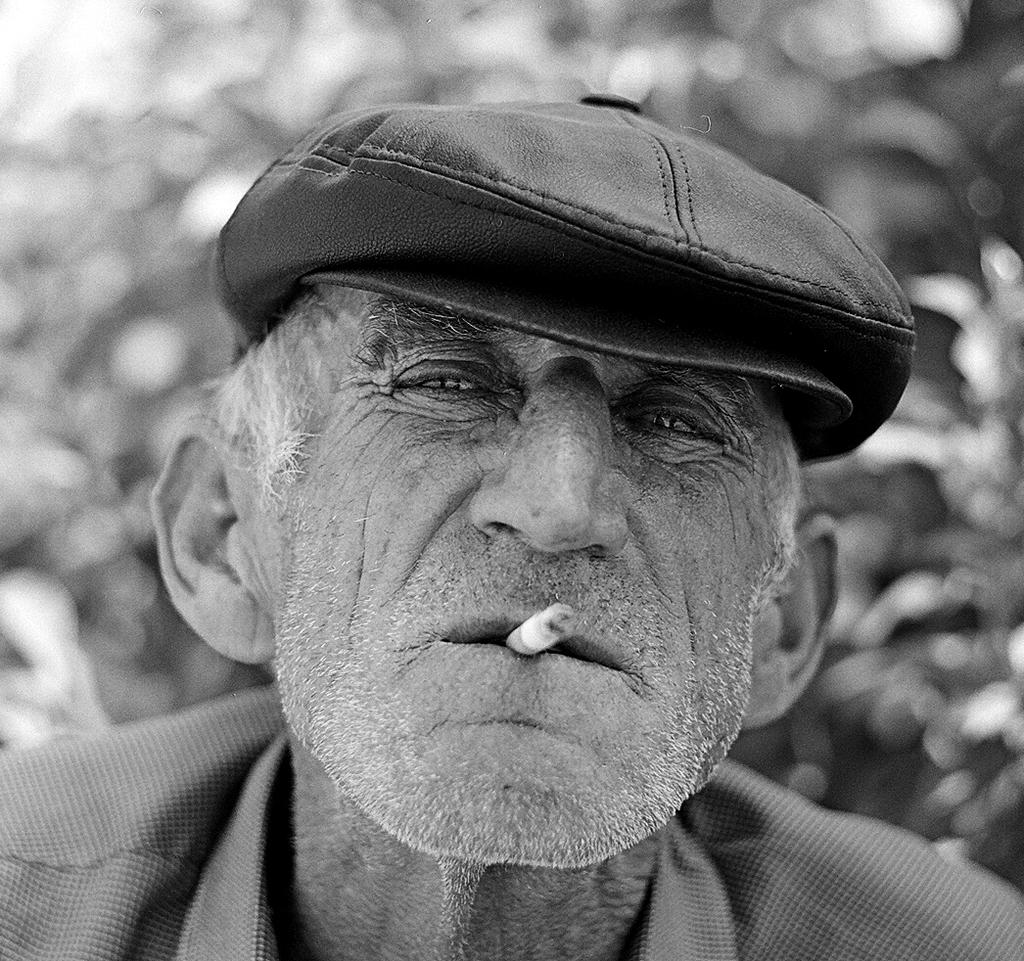What is the color scheme of the image? The image is black and white. Who is the main subject in the picture? There is an old man in the picture. What is the old man wearing on his head? The old man is wearing a cap. What activity is the old man engaged in? The old man is smoking. Where is the kitty playing near the river in the image? There is no kitty or river present in the image; it features an old man smoking. What type of quiver is the old man carrying in the image? There is no quiver present in the image; the old man is smoking and wearing a cap. 